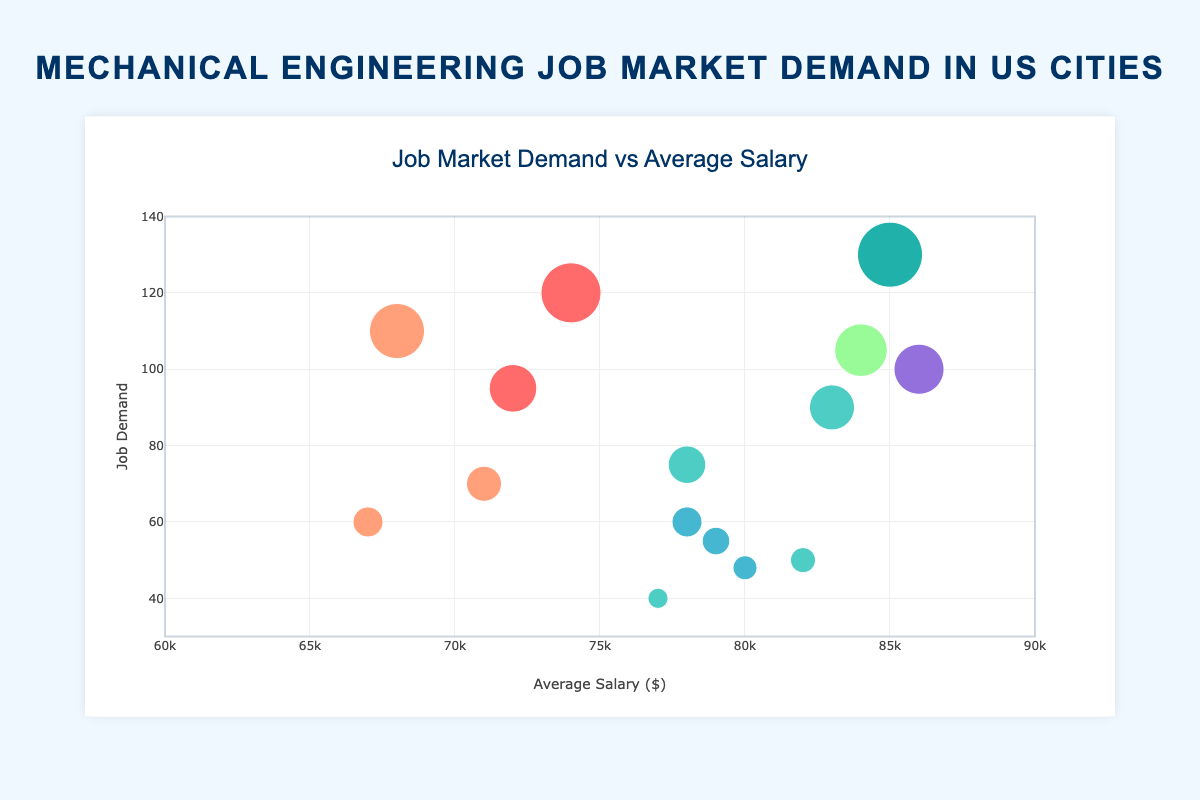How many data points are shown in the figure? The figure displays individual bubbles, each representing a data point combining city, industry sector, demand, and average salary. Count all unique bubbles to determine the number of data points.
Answer: 14 Which city has the highest job demand for mechanical engineering graduates? To answer this, identify the bubble positioned highest on the y-axis, as the y-axis represents job demand. The highest point indicates the highest demand.
Answer: Houston What is the average salary for a mechanical engineering job in New York's automotive sector? Locate the bubble for New York in the automotive sector and check its x-axis position, which represents the average salary.
Answer: $74,000 Which industry sector offers the highest average salary? Examine the x-coordinates of the bubbles (average salary) and identify the furthest to the right. Determine the industry sector associated with this bubble's text.
Answer: Technology How does the job demand in Houston's Oil & Gas sector compare to Chicago's Manufacturing sector? Find the respective bubbles for these sectors in these cities, noting their y-axis values (job demand) and compare them.
Answer: Houston's Oil & Gas sector has a higher demand (130 vs. 110) What’s the difference in the average salary between New York's Aerospace and Automotive sectors? Identify both bubbles representing New York’s Aerospace and Automotive sectors, note their x-axis values (average salary), and compute the difference.
Answer: $8,000 Which city has the most diverse range of industry sectors in the chart? Review the different industry sectors listed for each city in the text of the bubbles to see which has the most variety.
Answer: New York Between Los Angeles and San Francisco, which city offers a higher average salary in Renewable Energy? Locate the bubbles for Renewable Energy sector in both Los Angeles and San Francisco and compare their x-axis values (average salary).
Answer: Los Angeles What's the average job demand across all cities' Automotive sectors? Identify all bubbles associated with the Automotive sector, noting their y-values (job demand). Sum these values and divide by the number of automotive sector bubbles.
Answer: 105 (calculated as (120 + 95) / 2) Which industry sector in Houston provides a higher average salary? Locate both bubbles for Houston, noting their x-axis positions (average salary) and compare them.
Answer: Oil & Gas 